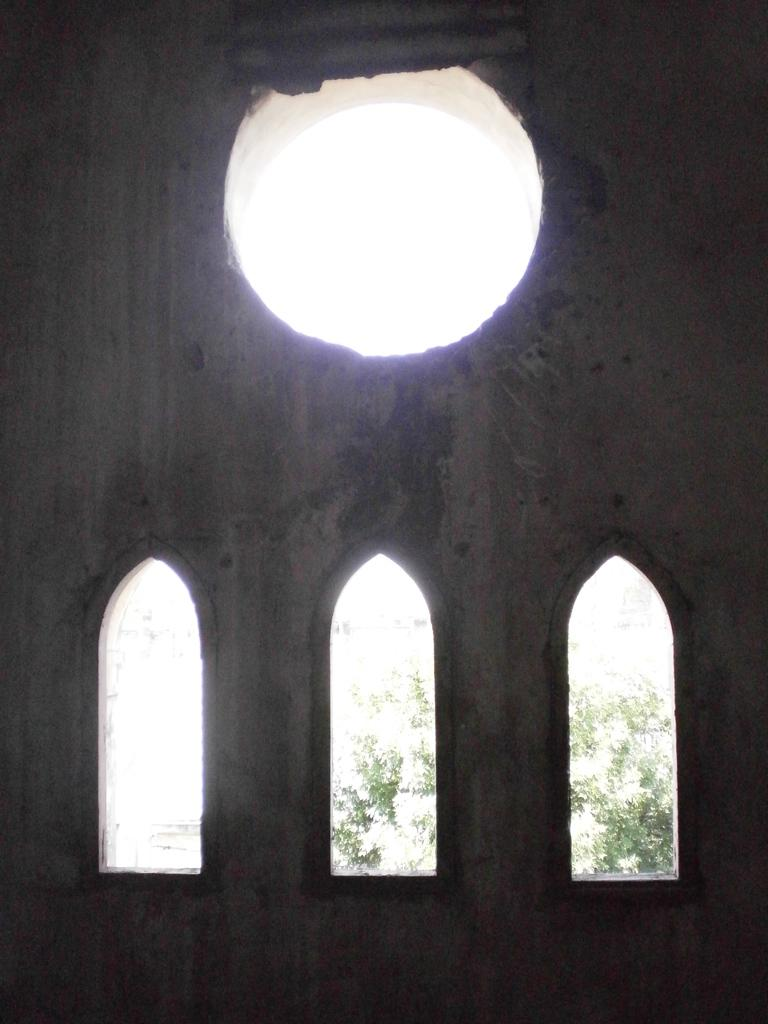What structures can be seen in the foreground of the image? There are arches in the foreground of the image, resembling windows. What are these arches part of? These arches are part of a wall. What feature is present at the top of the wall? There is a circular hole at the top of the wall. What can be seen in the background of the image? There are trees visible in the background of the image. How many beads are hanging from the cow in the image? There is no cow present in the image, and therefore no beads hanging from it. 